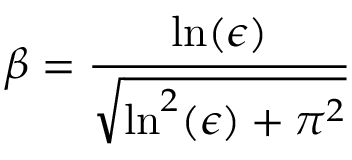Convert formula to latex. <formula><loc_0><loc_0><loc_500><loc_500>\beta = \frac { \ln ( \epsilon ) } { \sqrt { \ln ^ { 2 } ( \epsilon ) + \pi ^ { 2 } } }</formula> 